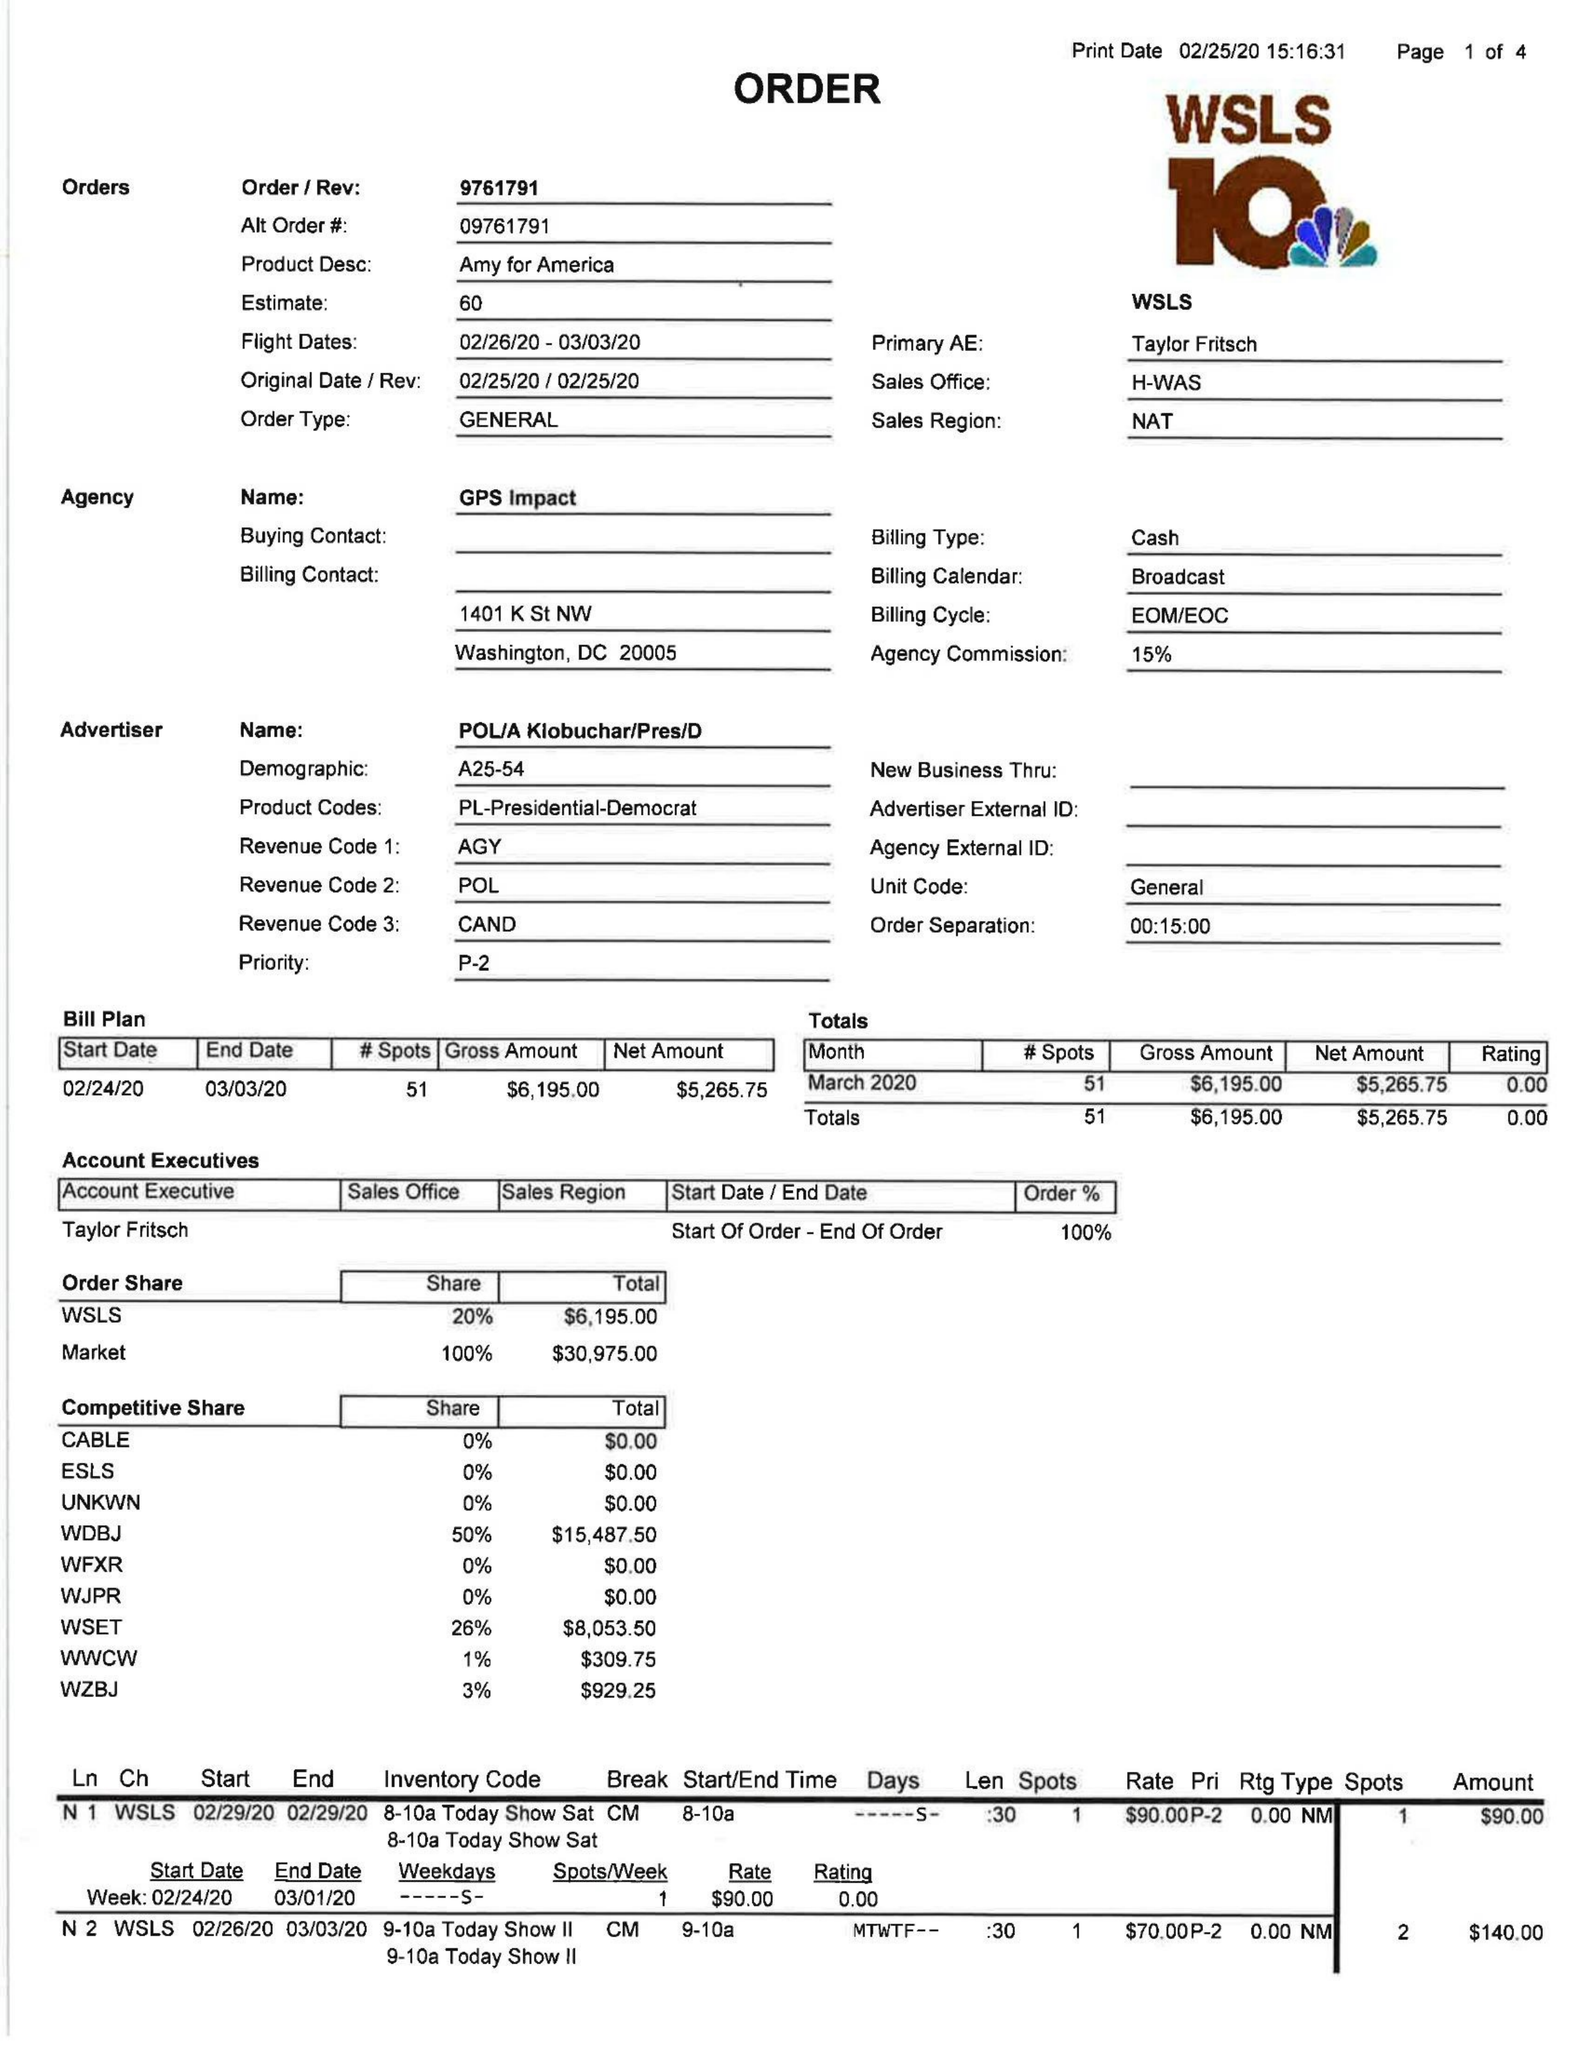What is the value for the contract_num?
Answer the question using a single word or phrase. 9761791 